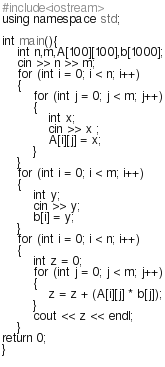<code> <loc_0><loc_0><loc_500><loc_500><_C++_>#include<iostream>
using namespace std;

int main(){
    int n,m,A[100][100],b[1000];
    cin >> n >> m;
    for (int i = 0; i < n; i++)
    {
        for (int j = 0; j < m; j++)
        {
            int x;
            cin >> x ;
            A[i][j] = x;
        }
    }
    for (int i = 0; i < m; i++)
    {
        int y;
        cin >> y;
        b[i] = y;
    }
    for (int i = 0; i < n; i++)
    {
        int z = 0;
        for (int j = 0; j < m; j++)
        {
            z = z + (A[i][j] * b[j]);
        }
        cout << z << endl;
    }
return 0;
}
    
</code> 